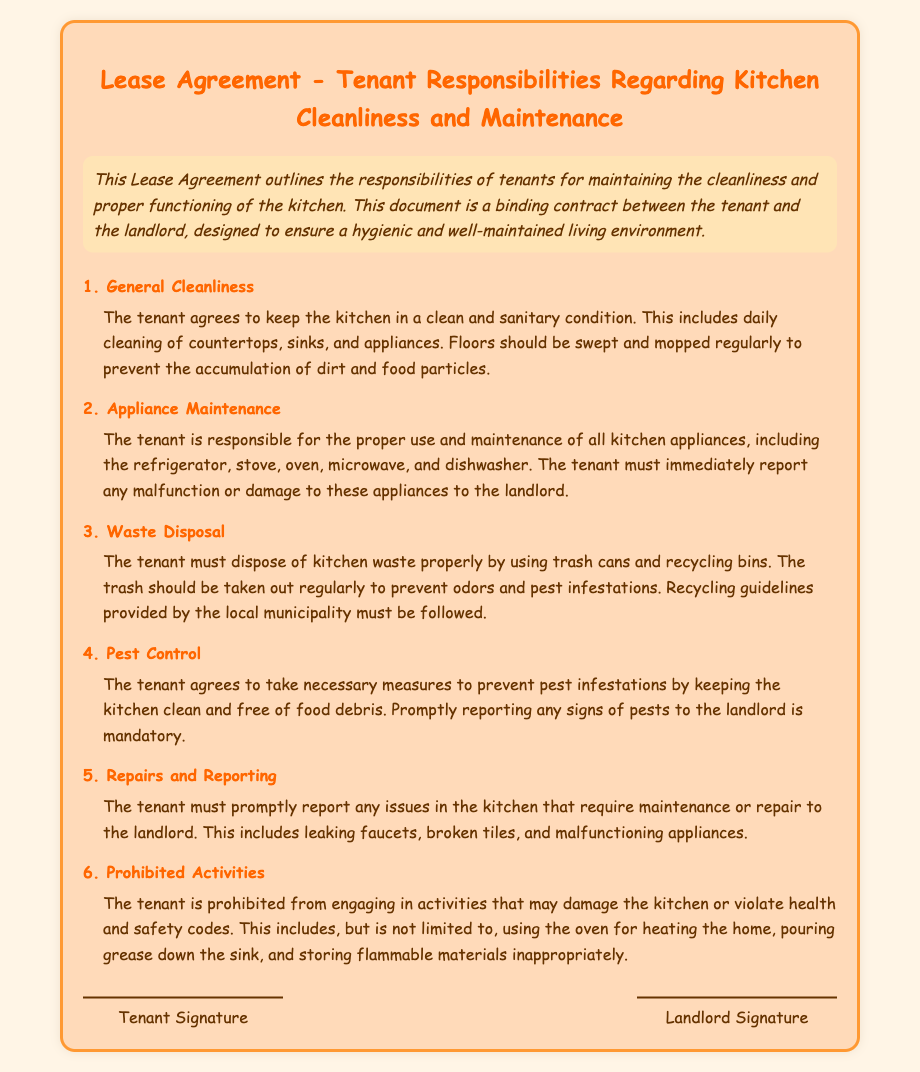What is the title of the document? The title of the document is found in the main heading section, which indicates the purpose of the document.
Answer: Lease Agreement - Tenant Responsibilities Regarding Kitchen Cleanliness and Maintenance What is the tenant's responsibility regarding appliance maintenance? This responsibility includes the proper use and maintenance of kitchen appliances with an obligation to report any malfunctions.
Answer: Proper use and maintenance How often should the floors be cleaned? The document specifies the frequency of cleaning floors to ensure hygiene in the kitchen area.
Answer: Regularly What should the tenant do if they notice a pest in the kitchen? The document states the necessary action the tenant must take upon observing signs of pests to maintain a pest-free kitchen.
Answer: Report to the landlord What activities are prohibited in the kitchen? The document lists specific harmful activities that tenants should avoid to maintain safety and cleanliness.
Answer: Heating the home with the oven What is the main purpose of this Lease Agreement? The document outlines the overarching goal in terms of tenant responsibilities regarding kitchen upkeep.
Answer: Ensure a hygienic and well-maintained living environment How must kitchen waste be disposed of? The document specifies the proper way to dispose of kitchen waste to maintain cleanliness and avoid issues.
Answer: Using trash cans and recycling bins 